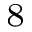Convert formula to latex. <formula><loc_0><loc_0><loc_500><loc_500>^ { 8 }</formula> 